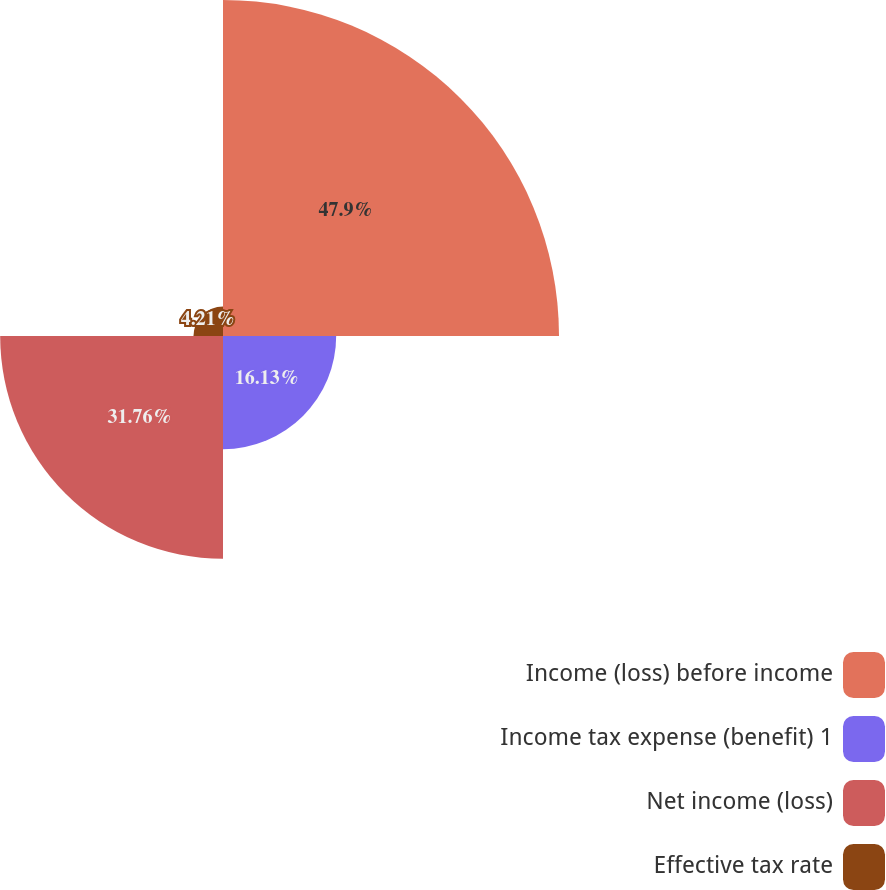<chart> <loc_0><loc_0><loc_500><loc_500><pie_chart><fcel>Income (loss) before income<fcel>Income tax expense (benefit) 1<fcel>Net income (loss)<fcel>Effective tax rate<nl><fcel>47.89%<fcel>16.13%<fcel>31.76%<fcel>4.21%<nl></chart> 